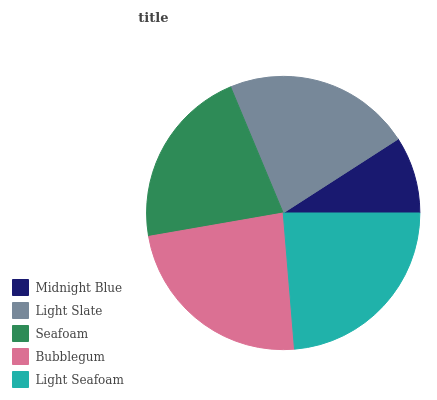Is Midnight Blue the minimum?
Answer yes or no. Yes. Is Light Seafoam the maximum?
Answer yes or no. Yes. Is Light Slate the minimum?
Answer yes or no. No. Is Light Slate the maximum?
Answer yes or no. No. Is Light Slate greater than Midnight Blue?
Answer yes or no. Yes. Is Midnight Blue less than Light Slate?
Answer yes or no. Yes. Is Midnight Blue greater than Light Slate?
Answer yes or no. No. Is Light Slate less than Midnight Blue?
Answer yes or no. No. Is Light Slate the high median?
Answer yes or no. Yes. Is Light Slate the low median?
Answer yes or no. Yes. Is Bubblegum the high median?
Answer yes or no. No. Is Bubblegum the low median?
Answer yes or no. No. 